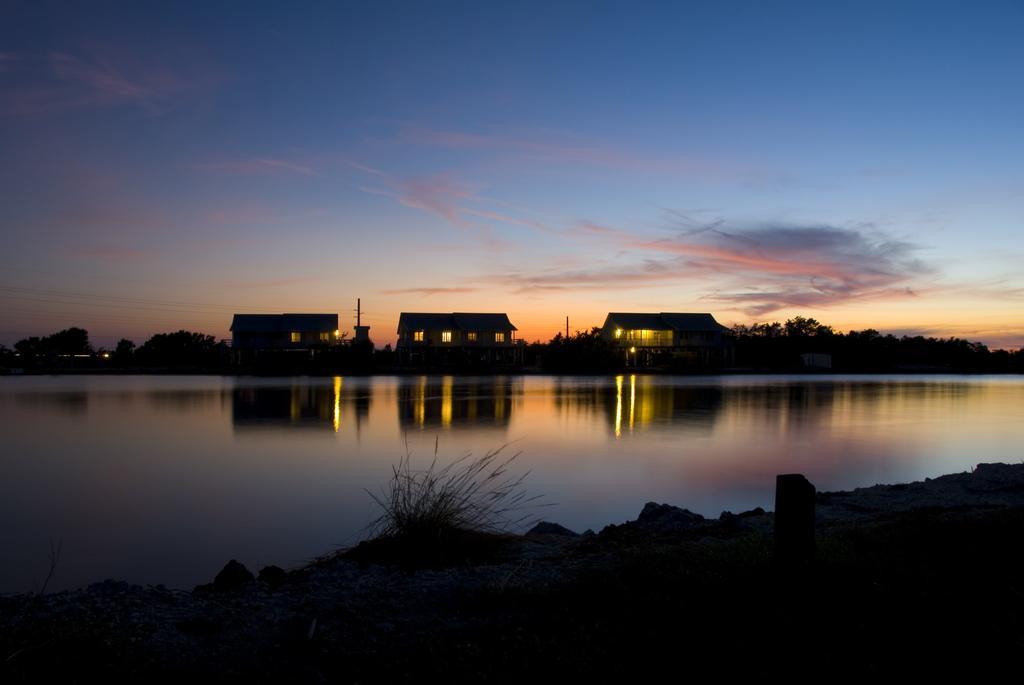Please provide a concise description of this image. In this image we can see sky with clouds, buildings, poles, trees, river, shrubs and stones. 